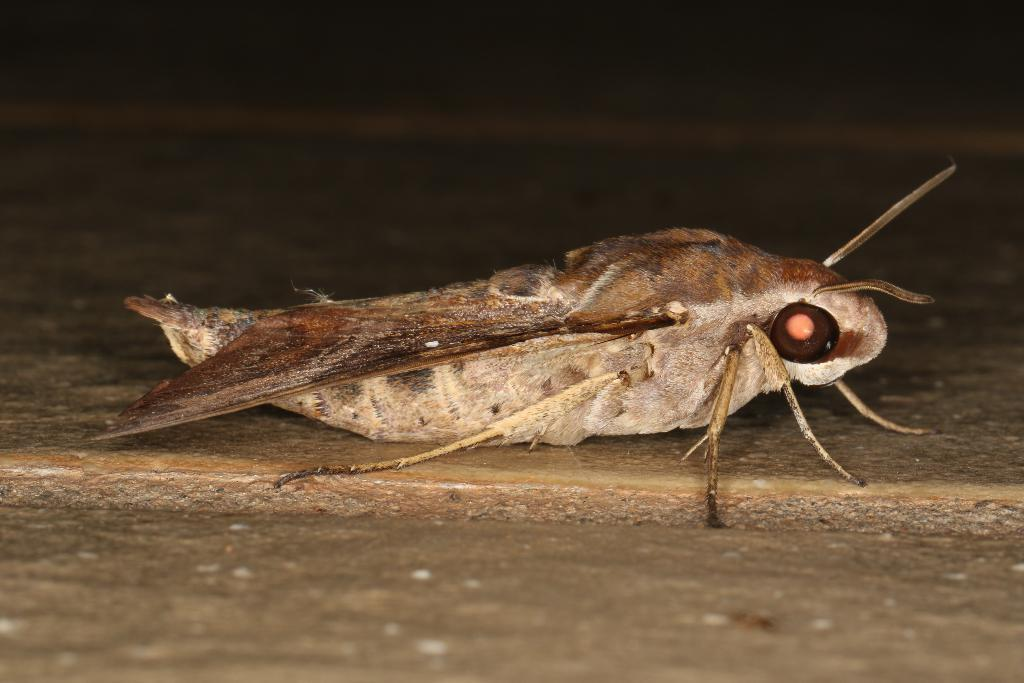What type of creature is in the image? There is an insect in the image. What does the insect resemble? The insect resembles a moth. What color is the insect? The insect is brown in color. What is visible at the bottom of the image? The bottom of the image contains the floor or pavement. What color is the background of the image? The background of the image is black in color. What is the tendency of the jellyfish in the image? There is no jellyfish present in the image. What type of cart is used to transport the insect in the image? There is no cart present in the image; the insect is not being transported. 